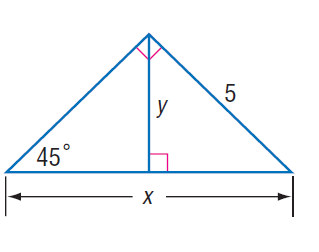Answer the mathemtical geometry problem and directly provide the correct option letter.
Question: Find x.
Choices: A: 5 B: 5 \sqrt { 2 } C: 10 D: 10 \sqrt { 2 } B 